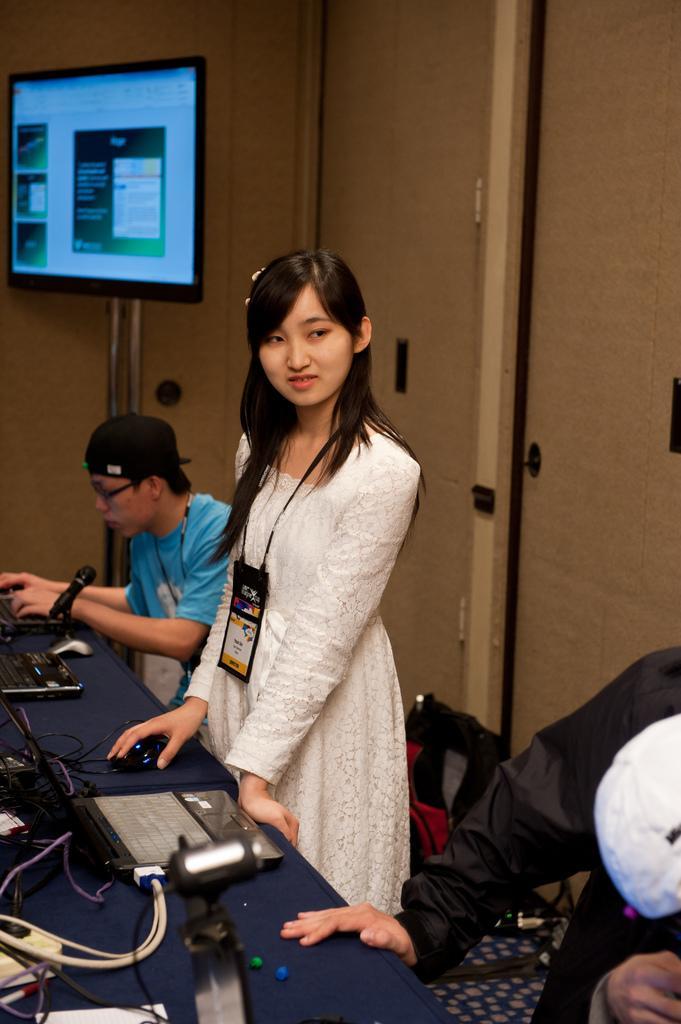Could you give a brief overview of what you see in this image? In the middle of the image we can see a woman wearing white dress and id card is standing in front of a table holding a mouse in her hand. To the right side of the image we can see a person standing. On the table we can see a microphone ,laptops ,mouse. In the background we can see a person wearing cap and spectacles is sitting and a television on the stand. 